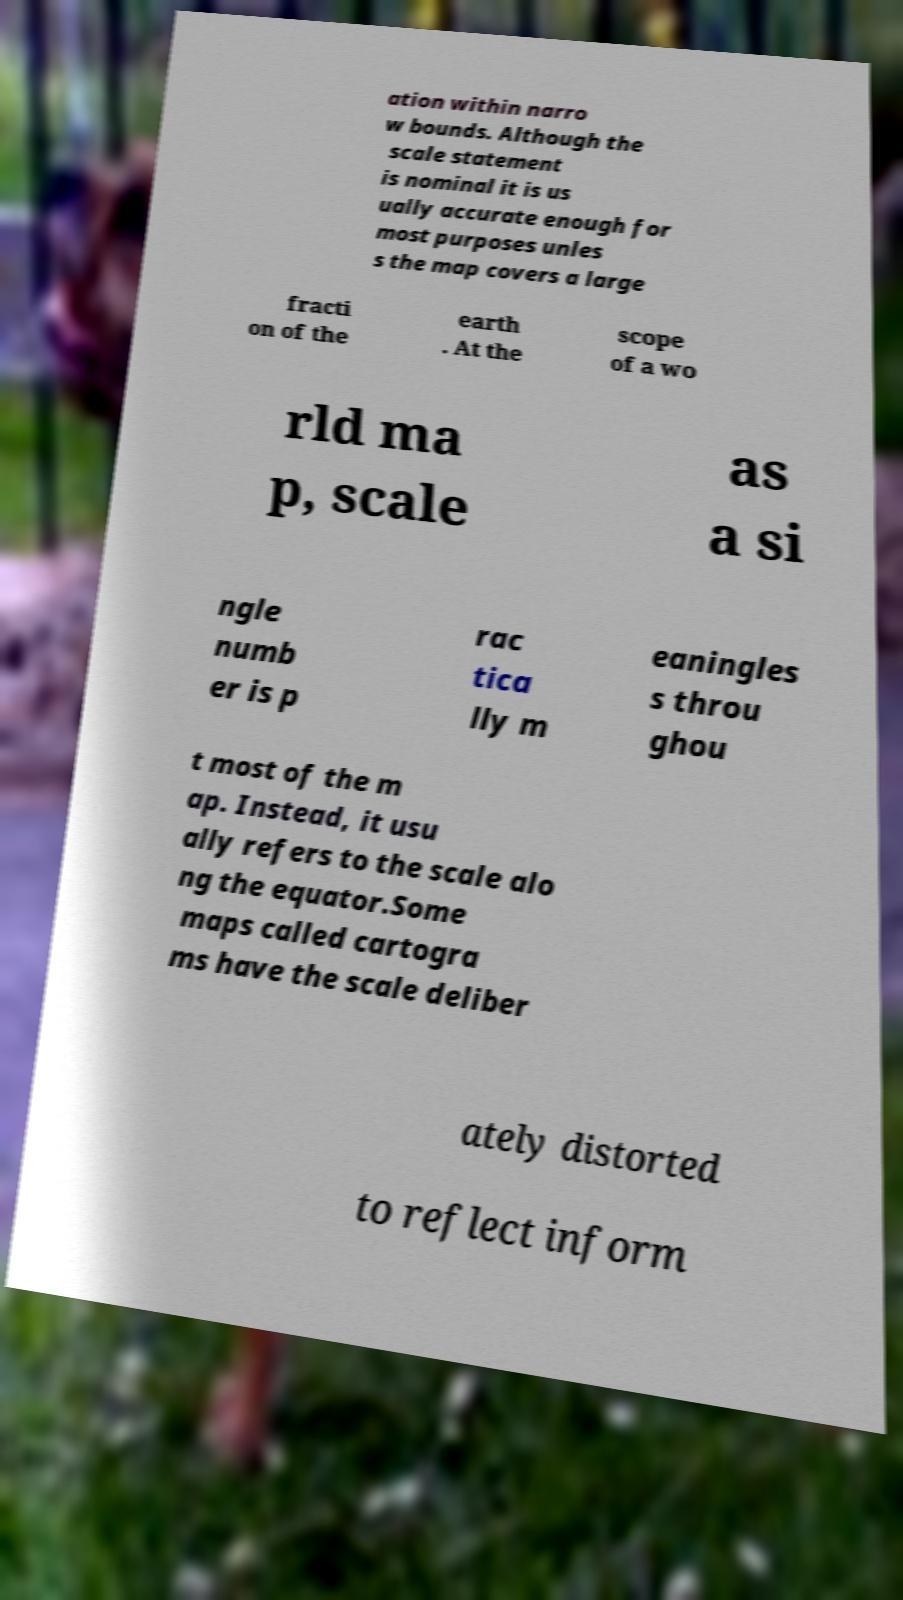Can you read and provide the text displayed in the image?This photo seems to have some interesting text. Can you extract and type it out for me? ation within narro w bounds. Although the scale statement is nominal it is us ually accurate enough for most purposes unles s the map covers a large fracti on of the earth . At the scope of a wo rld ma p, scale as a si ngle numb er is p rac tica lly m eaningles s throu ghou t most of the m ap. Instead, it usu ally refers to the scale alo ng the equator.Some maps called cartogra ms have the scale deliber ately distorted to reflect inform 